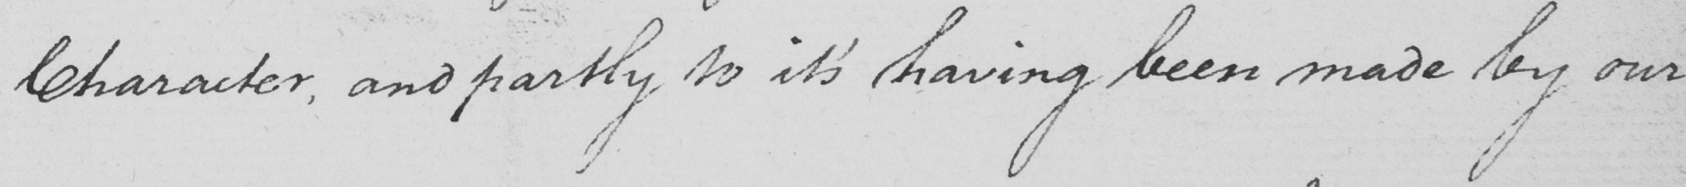Can you tell me what this handwritten text says? Character , and partly to it ' s having been made by our 